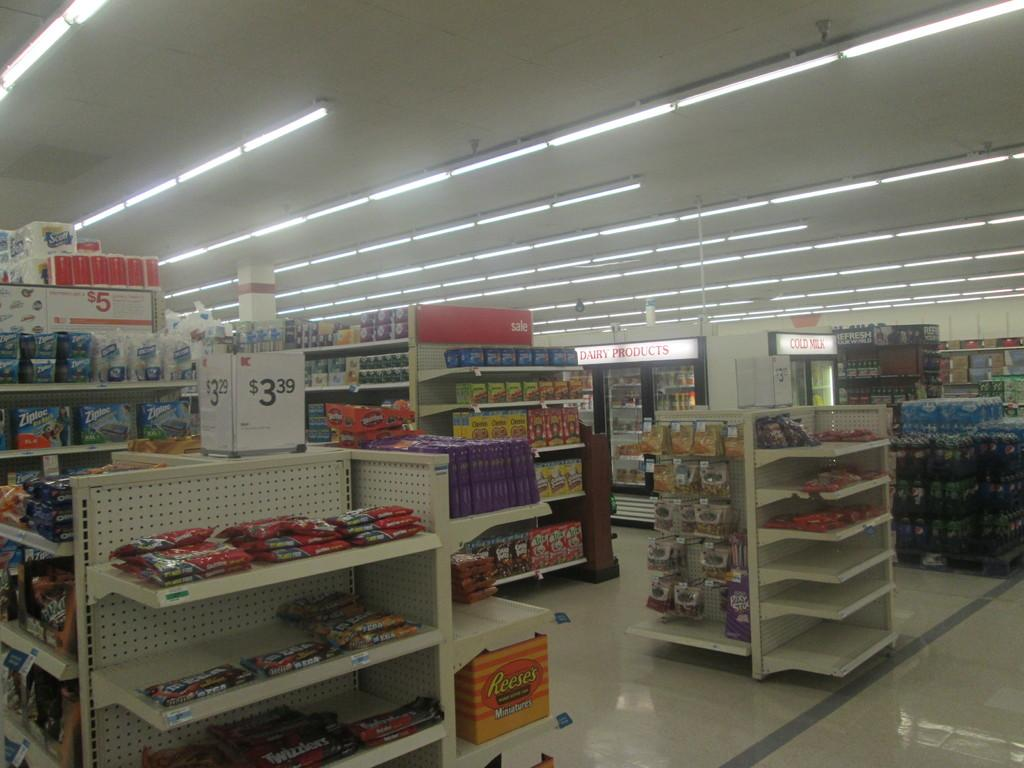<image>
Provide a brief description of the given image. Isles in the grocery store displaying Scott Tissue, Reese's Miniatures, Maxwell House Coffee, Cheerios Cereal, dairy products and various soft drinks. 